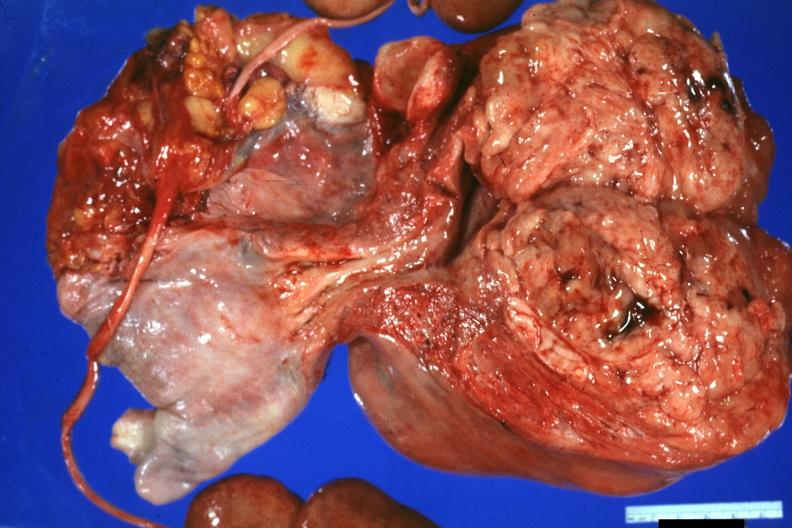what is present?
Answer the question using a single word or phrase. Leiomyosarcoma 